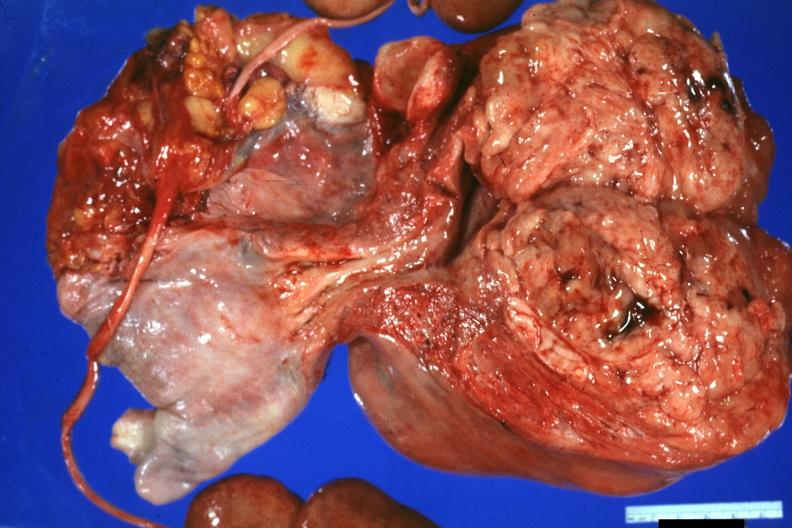what is present?
Answer the question using a single word or phrase. Leiomyosarcoma 